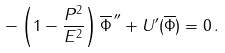<formula> <loc_0><loc_0><loc_500><loc_500>- \left ( 1 - \frac { P ^ { 2 } } { E ^ { 2 } } \right ) \overline { \Phi } ^ { \, \prime \prime } + U ^ { \prime } ( \overline { \Phi } ) = 0 \, .</formula> 